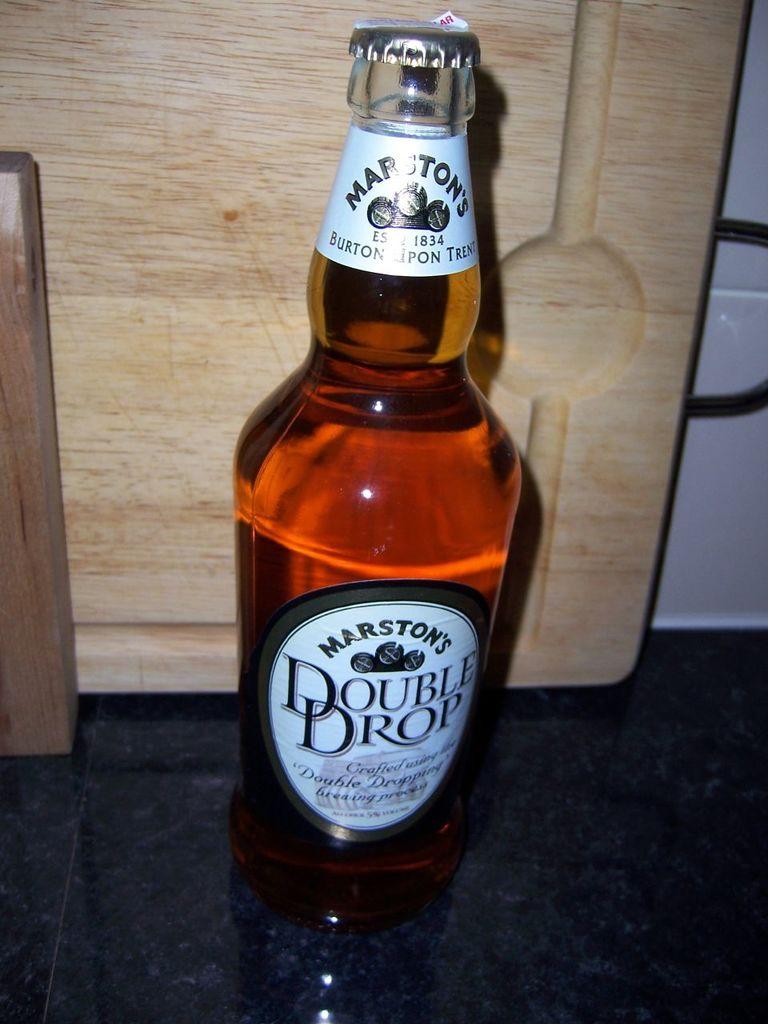What is the brand of the drink?
Keep it short and to the point. Marston's. 